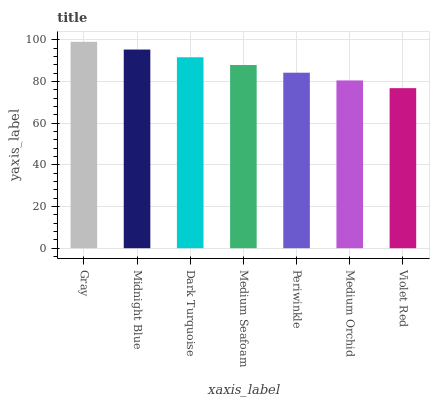Is Violet Red the minimum?
Answer yes or no. Yes. Is Gray the maximum?
Answer yes or no. Yes. Is Midnight Blue the minimum?
Answer yes or no. No. Is Midnight Blue the maximum?
Answer yes or no. No. Is Gray greater than Midnight Blue?
Answer yes or no. Yes. Is Midnight Blue less than Gray?
Answer yes or no. Yes. Is Midnight Blue greater than Gray?
Answer yes or no. No. Is Gray less than Midnight Blue?
Answer yes or no. No. Is Medium Seafoam the high median?
Answer yes or no. Yes. Is Medium Seafoam the low median?
Answer yes or no. Yes. Is Periwinkle the high median?
Answer yes or no. No. Is Medium Orchid the low median?
Answer yes or no. No. 